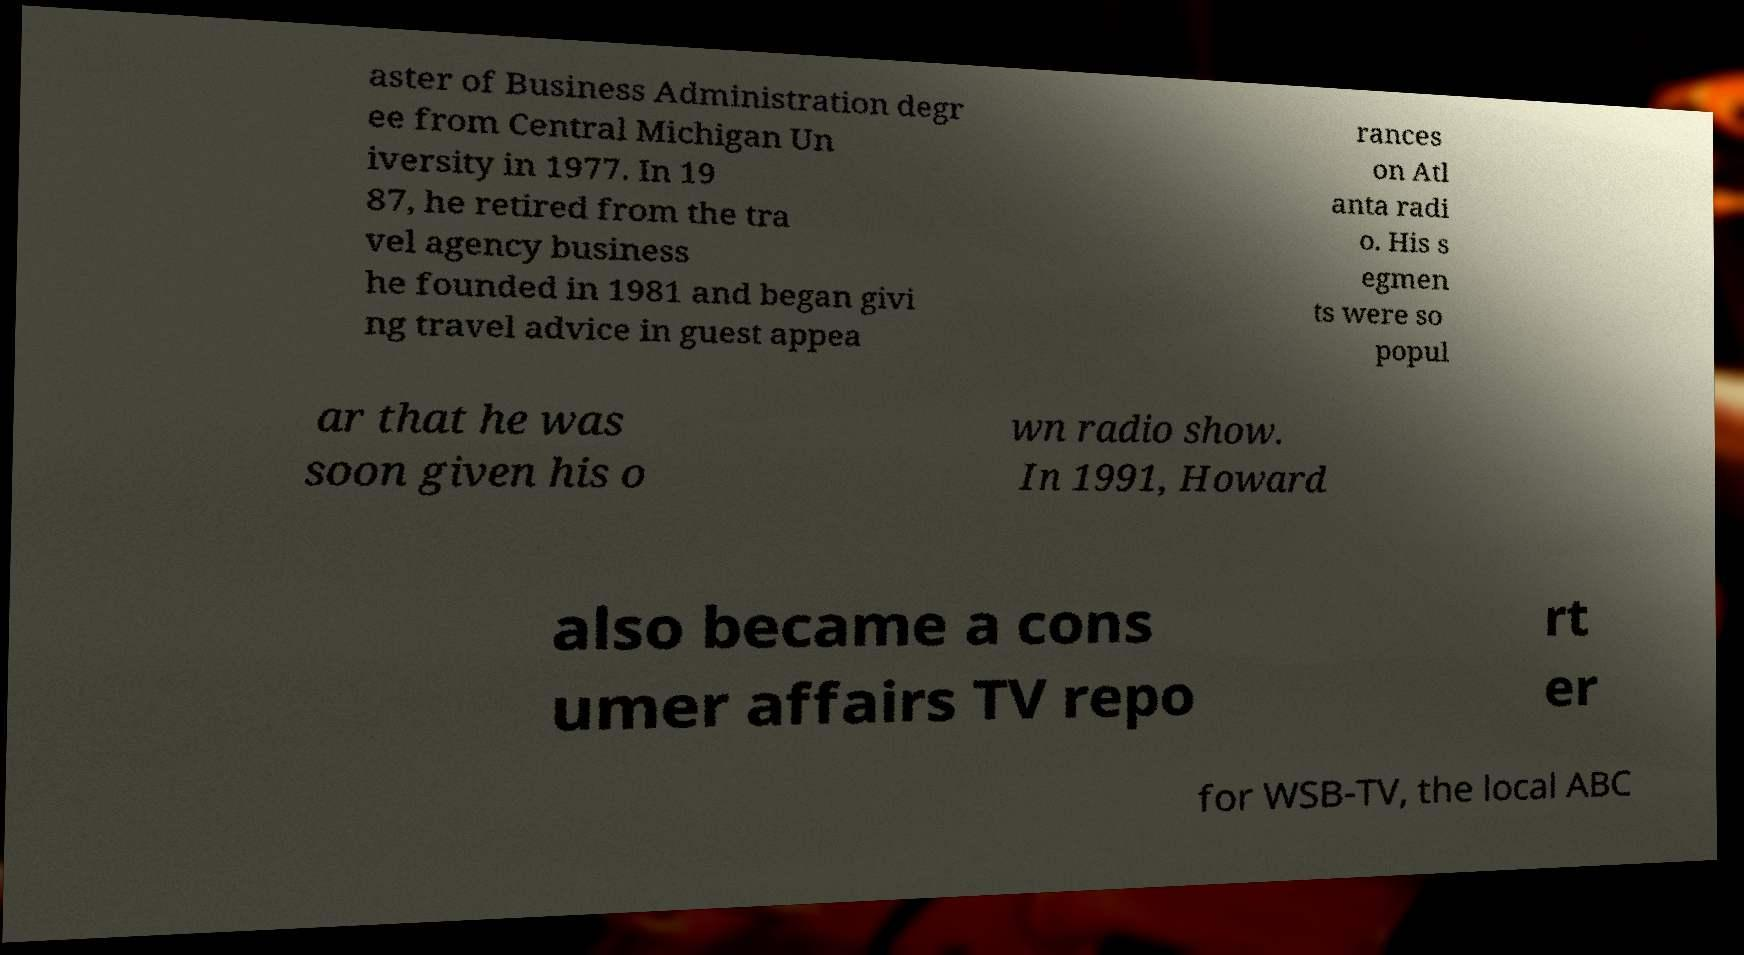Please identify and transcribe the text found in this image. aster of Business Administration degr ee from Central Michigan Un iversity in 1977. In 19 87, he retired from the tra vel agency business he founded in 1981 and began givi ng travel advice in guest appea rances on Atl anta radi o. His s egmen ts were so popul ar that he was soon given his o wn radio show. In 1991, Howard also became a cons umer affairs TV repo rt er for WSB-TV, the local ABC 